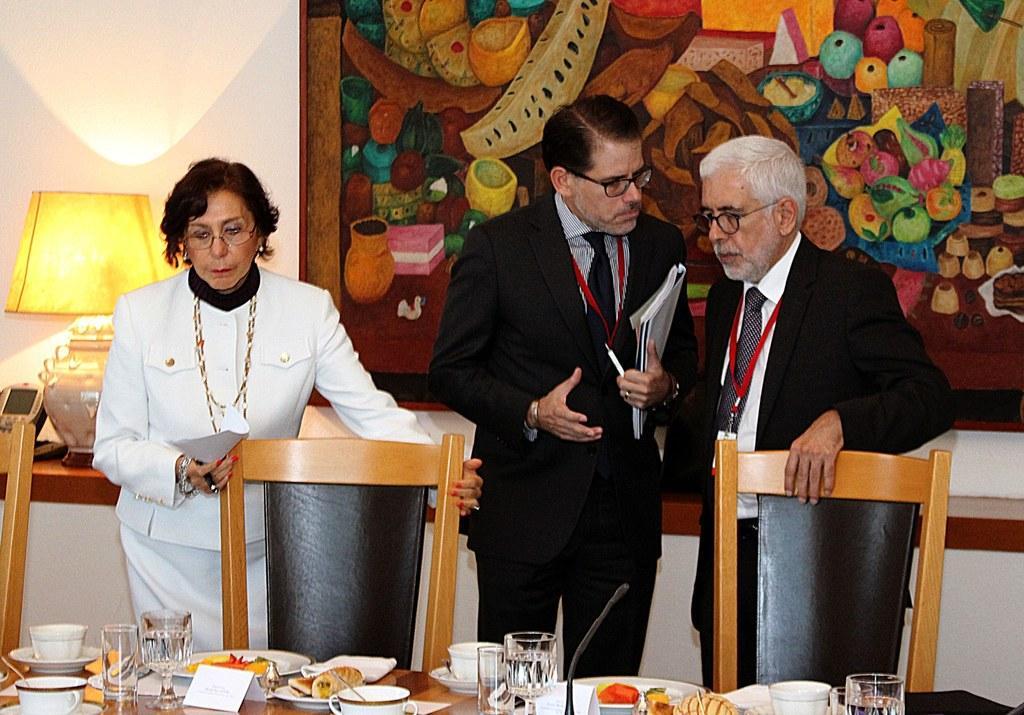In one or two sentences, can you explain what this image depicts? On the background we can see a wall and a photo frame and a table lamp. Here we can see three persons standing in front of a chairs and table and on the table we can see water glasses, cups and saucers and a plate of food , board. We can see this man and woman holding a pen and papers in their hands. 